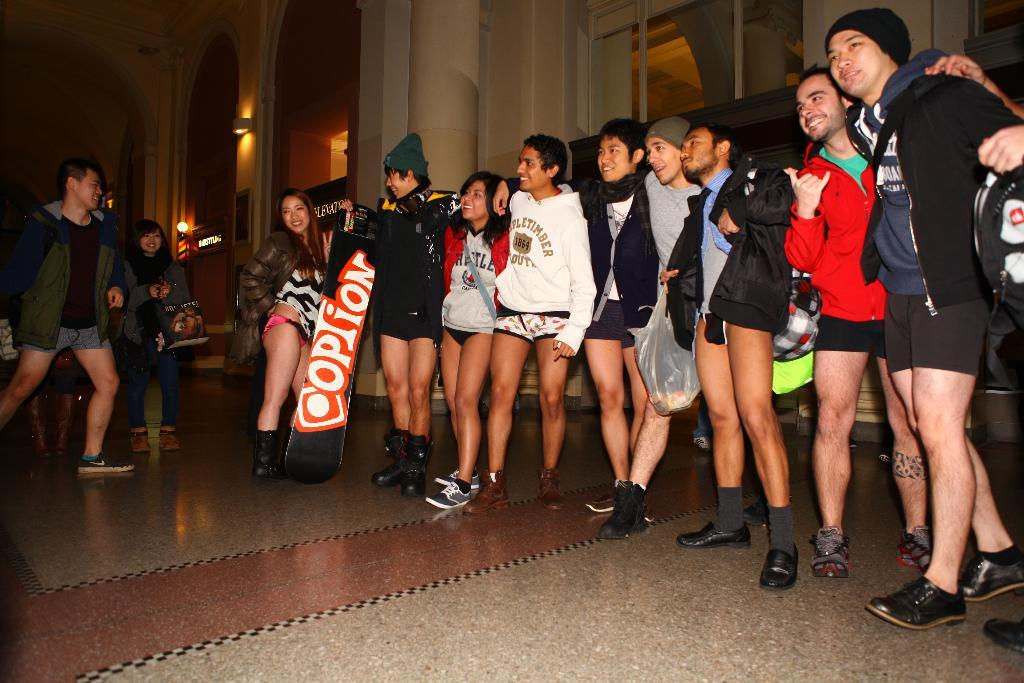<image>
Write a terse but informative summary of the picture. A line of people stand in a line with a girl holding a sign that says option. 